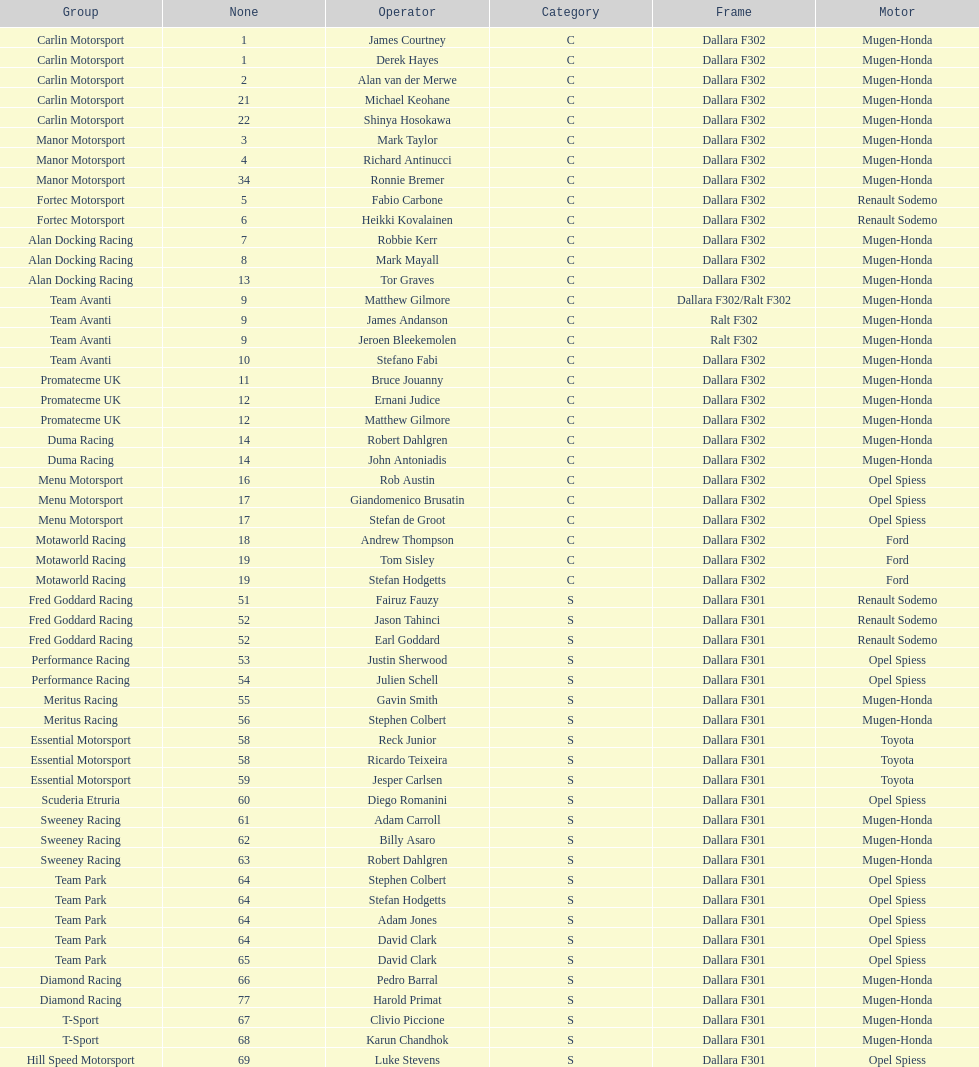Who had more drivers, team avanti or motaworld racing? Team Avanti. 